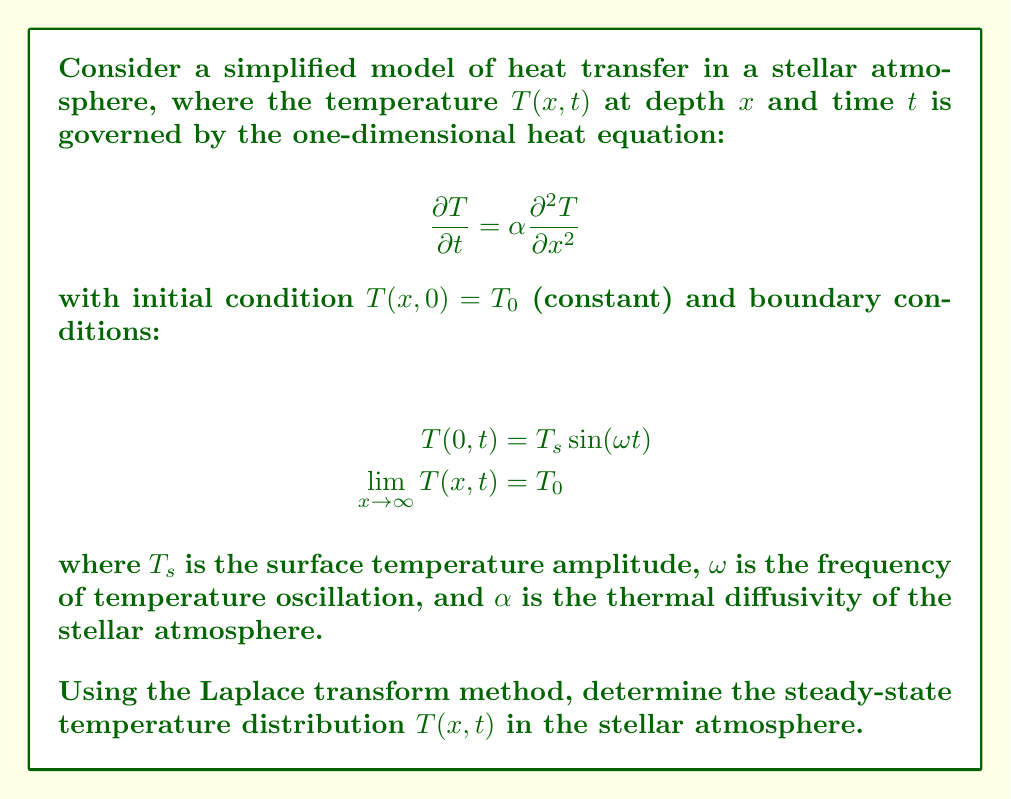Solve this math problem. Let's approach this problem step-by-step using the Laplace transform method:

1) First, let's define the Laplace transform of $T(x,t)$ with respect to $t$:

   $$\mathcal{L}\{T(x,t)\} = \int_0^\infty T(x,t)e^{-st}dt = \bar{T}(x,s)$$

2) Taking the Laplace transform of the heat equation:

   $$\mathcal{L}\{\frac{\partial T}{\partial t}\} = \alpha \mathcal{L}\{\frac{\partial^2 T}{\partial x^2}\}$$

   $$s\bar{T}(x,s) - T(x,0) = \alpha \frac{d^2\bar{T}}{dx^2}$$

3) Substituting the initial condition:

   $$s\bar{T}(x,s) - T_0 = \alpha \frac{d^2\bar{T}}{dx^2}$$

4) Rearranging:

   $$\frac{d^2\bar{T}}{dx^2} - \frac{s}{\alpha}\bar{T} = -\frac{T_0}{\alpha}$$

5) This is a second-order ODE with constant coefficients. The general solution is:

   $$\bar{T}(x,s) = Ae^{-x\sqrt{s/\alpha}} + Be^{x\sqrt{s/\alpha}} + \frac{T_0}{s}$$

6) Applying the boundary condition at infinity:

   $$\lim_{x \to \infty} \bar{T}(x,s) = \frac{T_0}{s}$$

   This implies $B = 0$.

7) For the boundary condition at $x=0$:

   $$\mathcal{L}\{T_s \sin(\omega t)\} = \frac{T_s\omega}{s^2 + \omega^2}$$

8) Therefore:

   $$\bar{T}(0,s) = A + \frac{T_0}{s} = \frac{T_s\omega}{s^2 + \omega^2}$$

   $$A = \frac{T_s\omega}{s^2 + \omega^2} - \frac{T_0}{s}$$

9) The transformed solution is:

   $$\bar{T}(x,s) = (\frac{T_s\omega}{s^2 + \omega^2} - \frac{T_0}{s})e^{-x\sqrt{s/\alpha}} + \frac{T_0}{s}$$

10) To find the steady-state solution, we need to find the inverse Laplace transform of the terms with $s$ in the denominator:

    $$T(x,t) = T_0 + T_s e^{-x\sqrt{\omega/(2\alpha)}} \sin(\omega t - x\sqrt{\omega/(2\alpha)})$$

This represents the steady-state temperature distribution in the stellar atmosphere.
Answer: $$T(x,t) = T_0 + T_s e^{-x\sqrt{\omega/(2\alpha)}} \sin(\omega t - x\sqrt{\omega/(2\alpha)})$$ 